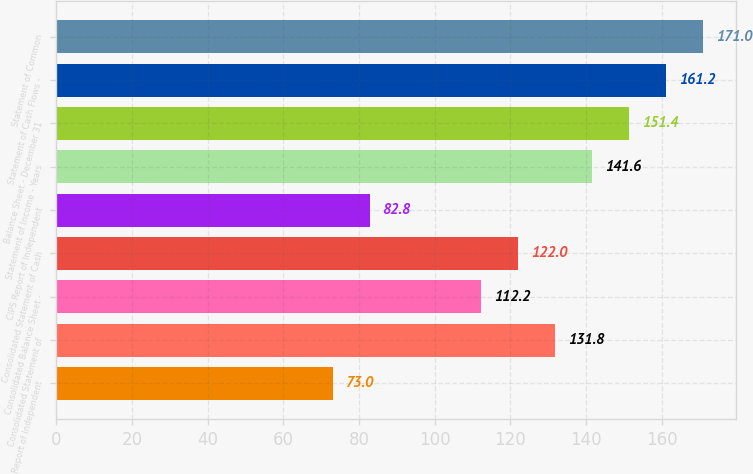Convert chart. <chart><loc_0><loc_0><loc_500><loc_500><bar_chart><fcel>Report of Independent<fcel>Consolidated Statement of<fcel>Consolidated Balance Sheet -<fcel>Consolidated Statement of Cash<fcel>CIPS Report of Independent<fcel>Statement of Income - Years<fcel>Balance Sheet - December 31<fcel>Statement of Cash Flows -<fcel>Statement of Common<nl><fcel>73<fcel>131.8<fcel>112.2<fcel>122<fcel>82.8<fcel>141.6<fcel>151.4<fcel>161.2<fcel>171<nl></chart> 